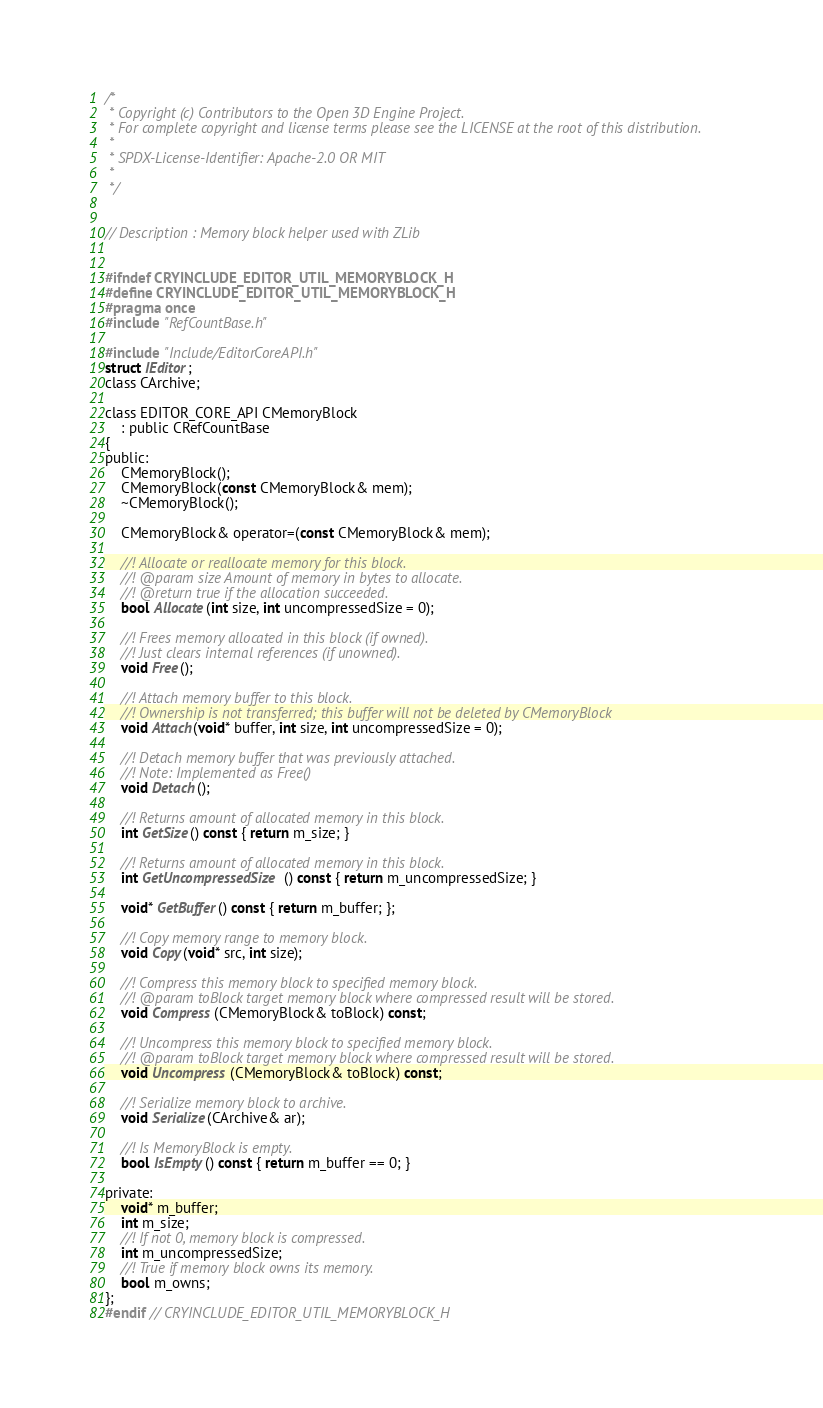<code> <loc_0><loc_0><loc_500><loc_500><_C_>/*
 * Copyright (c) Contributors to the Open 3D Engine Project.
 * For complete copyright and license terms please see the LICENSE at the root of this distribution.
 *
 * SPDX-License-Identifier: Apache-2.0 OR MIT
 *
 */


// Description : Memory block helper used with ZLib


#ifndef CRYINCLUDE_EDITOR_UTIL_MEMORYBLOCK_H
#define CRYINCLUDE_EDITOR_UTIL_MEMORYBLOCK_H
#pragma once
#include "RefCountBase.h"

#include "Include/EditorCoreAPI.h"
struct IEditor;
class CArchive;

class EDITOR_CORE_API CMemoryBlock
    : public CRefCountBase
{
public:
    CMemoryBlock();
    CMemoryBlock(const CMemoryBlock& mem);
    ~CMemoryBlock();

    CMemoryBlock& operator=(const CMemoryBlock& mem);

    //! Allocate or reallocate memory for this block.
    //! @param size Amount of memory in bytes to allocate.
    //! @return true if the allocation succeeded.
    bool Allocate(int size, int uncompressedSize = 0);

    //! Frees memory allocated in this block (if owned).
    //! Just clears internal references (if unowned).
    void Free();

    //! Attach memory buffer to this block.
    //! Ownership is not transferred; this buffer will not be deleted by CMemoryBlock
    void Attach(void* buffer, int size, int uncompressedSize = 0);

    //! Detach memory buffer that was previously attached.
    //! Note: Implemented as Free()
    void Detach();

    //! Returns amount of allocated memory in this block.
    int GetSize() const { return m_size; }

    //! Returns amount of allocated memory in this block.
    int GetUncompressedSize() const { return m_uncompressedSize; }

    void* GetBuffer() const { return m_buffer; };

    //! Copy memory range to memory block.
    void Copy(void* src, int size);

    //! Compress this memory block to specified memory block.
    //! @param toBlock target memory block where compressed result will be stored.
    void Compress(CMemoryBlock& toBlock) const;

    //! Uncompress this memory block to specified memory block.
    //! @param toBlock target memory block where compressed result will be stored.
    void Uncompress(CMemoryBlock& toBlock) const;

    //! Serialize memory block to archive.
    void Serialize(CArchive& ar);

    //! Is MemoryBlock is empty.
    bool IsEmpty() const { return m_buffer == 0; }

private:
    void* m_buffer;
    int m_size;
    //! If not 0, memory block is compressed.
    int m_uncompressedSize;
    //! True if memory block owns its memory.
    bool m_owns;
};
#endif // CRYINCLUDE_EDITOR_UTIL_MEMORYBLOCK_H
</code> 